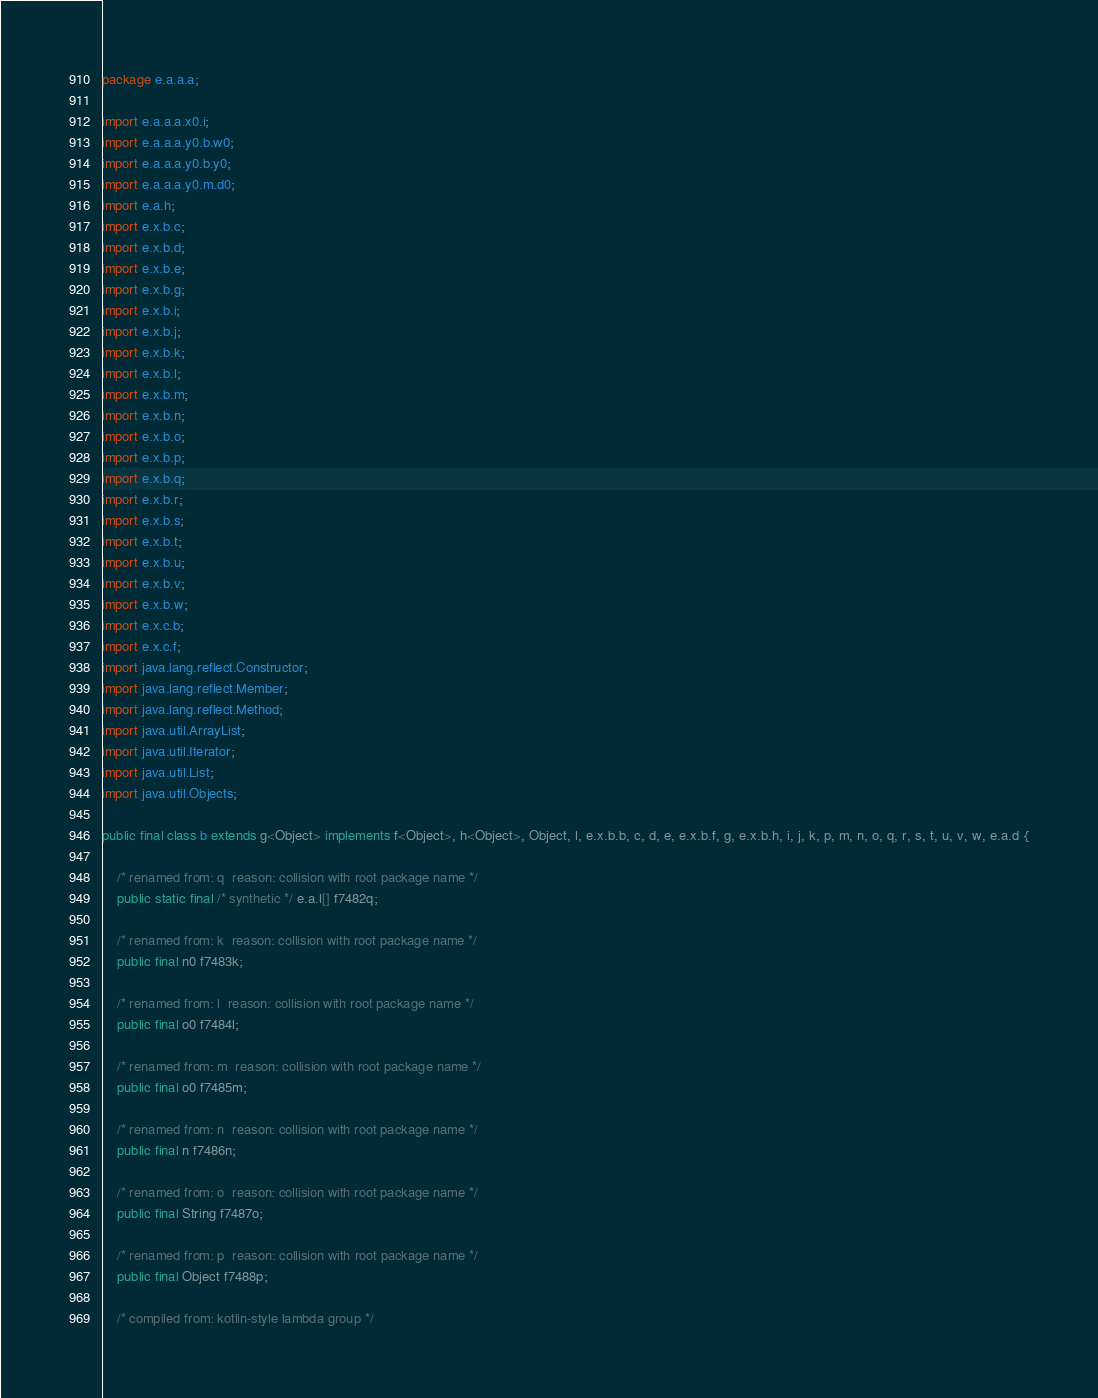Convert code to text. <code><loc_0><loc_0><loc_500><loc_500><_Java_>package e.a.a.a;

import e.a.a.a.x0.i;
import e.a.a.a.y0.b.w0;
import e.a.a.a.y0.b.y0;
import e.a.a.a.y0.m.d0;
import e.a.h;
import e.x.b.c;
import e.x.b.d;
import e.x.b.e;
import e.x.b.g;
import e.x.b.i;
import e.x.b.j;
import e.x.b.k;
import e.x.b.l;
import e.x.b.m;
import e.x.b.n;
import e.x.b.o;
import e.x.b.p;
import e.x.b.q;
import e.x.b.r;
import e.x.b.s;
import e.x.b.t;
import e.x.b.u;
import e.x.b.v;
import e.x.b.w;
import e.x.c.b;
import e.x.c.f;
import java.lang.reflect.Constructor;
import java.lang.reflect.Member;
import java.lang.reflect.Method;
import java.util.ArrayList;
import java.util.Iterator;
import java.util.List;
import java.util.Objects;

public final class b extends g<Object> implements f<Object>, h<Object>, Object, l, e.x.b.b, c, d, e, e.x.b.f, g, e.x.b.h, i, j, k, p, m, n, o, q, r, s, t, u, v, w, e.a.d {

    /* renamed from: q  reason: collision with root package name */
    public static final /* synthetic */ e.a.l[] f7482q;

    /* renamed from: k  reason: collision with root package name */
    public final n0 f7483k;

    /* renamed from: l  reason: collision with root package name */
    public final o0 f7484l;

    /* renamed from: m  reason: collision with root package name */
    public final o0 f7485m;

    /* renamed from: n  reason: collision with root package name */
    public final n f7486n;

    /* renamed from: o  reason: collision with root package name */
    public final String f7487o;

    /* renamed from: p  reason: collision with root package name */
    public final Object f7488p;

    /* compiled from: kotlin-style lambda group */</code> 